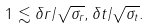<formula> <loc_0><loc_0><loc_500><loc_500>1 \lesssim \delta r / \sqrt { \sigma _ { r } } , \delta t / \sqrt { \sigma _ { t } } .</formula> 